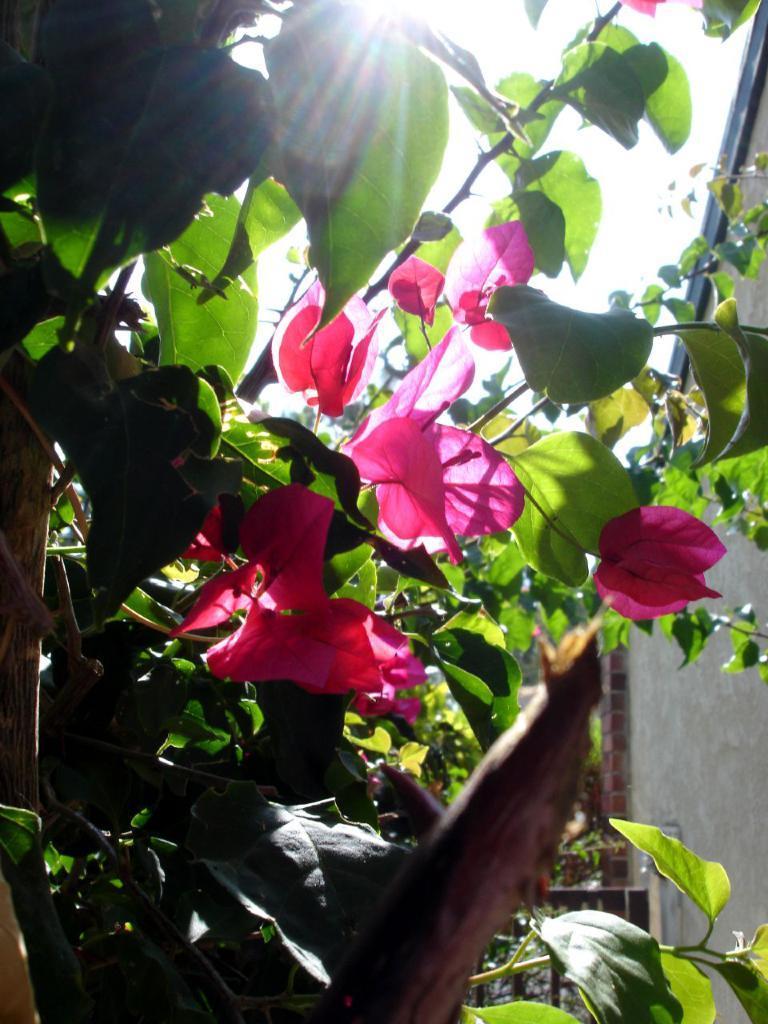Can you describe this image briefly? In this picture we can see flowers, leaves and stems. In the background of the image we can see wall. 